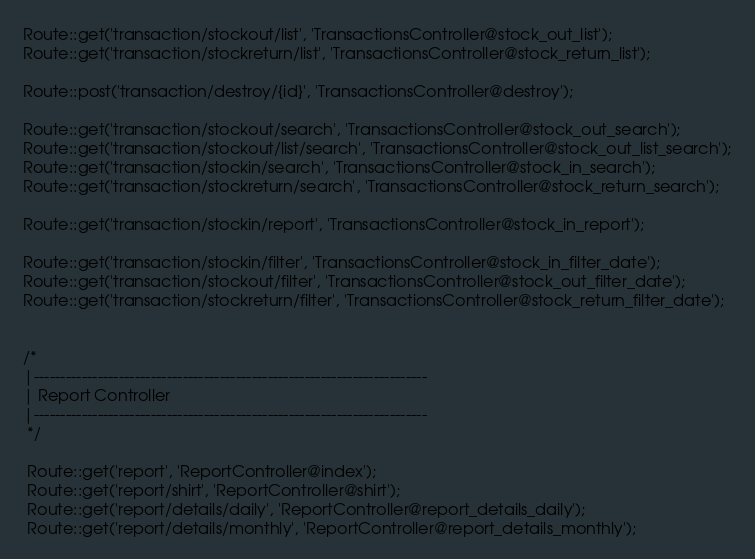<code> <loc_0><loc_0><loc_500><loc_500><_PHP_>Route::get('transaction/stockout/list', 'TransactionsController@stock_out_list');
Route::get('transaction/stockreturn/list', 'TransactionsController@stock_return_list');

Route::post('transaction/destroy/{id}', 'TransactionsController@destroy');

Route::get('transaction/stockout/search', 'TransactionsController@stock_out_search');
Route::get('transaction/stockout/list/search', 'TransactionsController@stock_out_list_search');
Route::get('transaction/stockin/search', 'TransactionsController@stock_in_search');
Route::get('transaction/stockreturn/search', 'TransactionsController@stock_return_search');

Route::get('transaction/stockin/report', 'TransactionsController@stock_in_report');

Route::get('transaction/stockin/filter', 'TransactionsController@stock_in_filter_date');
Route::get('transaction/stockout/filter', 'TransactionsController@stock_out_filter_date');
Route::get('transaction/stockreturn/filter', 'TransactionsController@stock_return_filter_date');


/*
|--------------------------------------------------------------------------
| Report Controller
|--------------------------------------------------------------------------
 */

 Route::get('report', 'ReportController@index');
 Route::get('report/shirt', 'ReportController@shirt');
 Route::get('report/details/daily', 'ReportController@report_details_daily');
 Route::get('report/details/monthly', 'ReportController@report_details_monthly');



</code> 